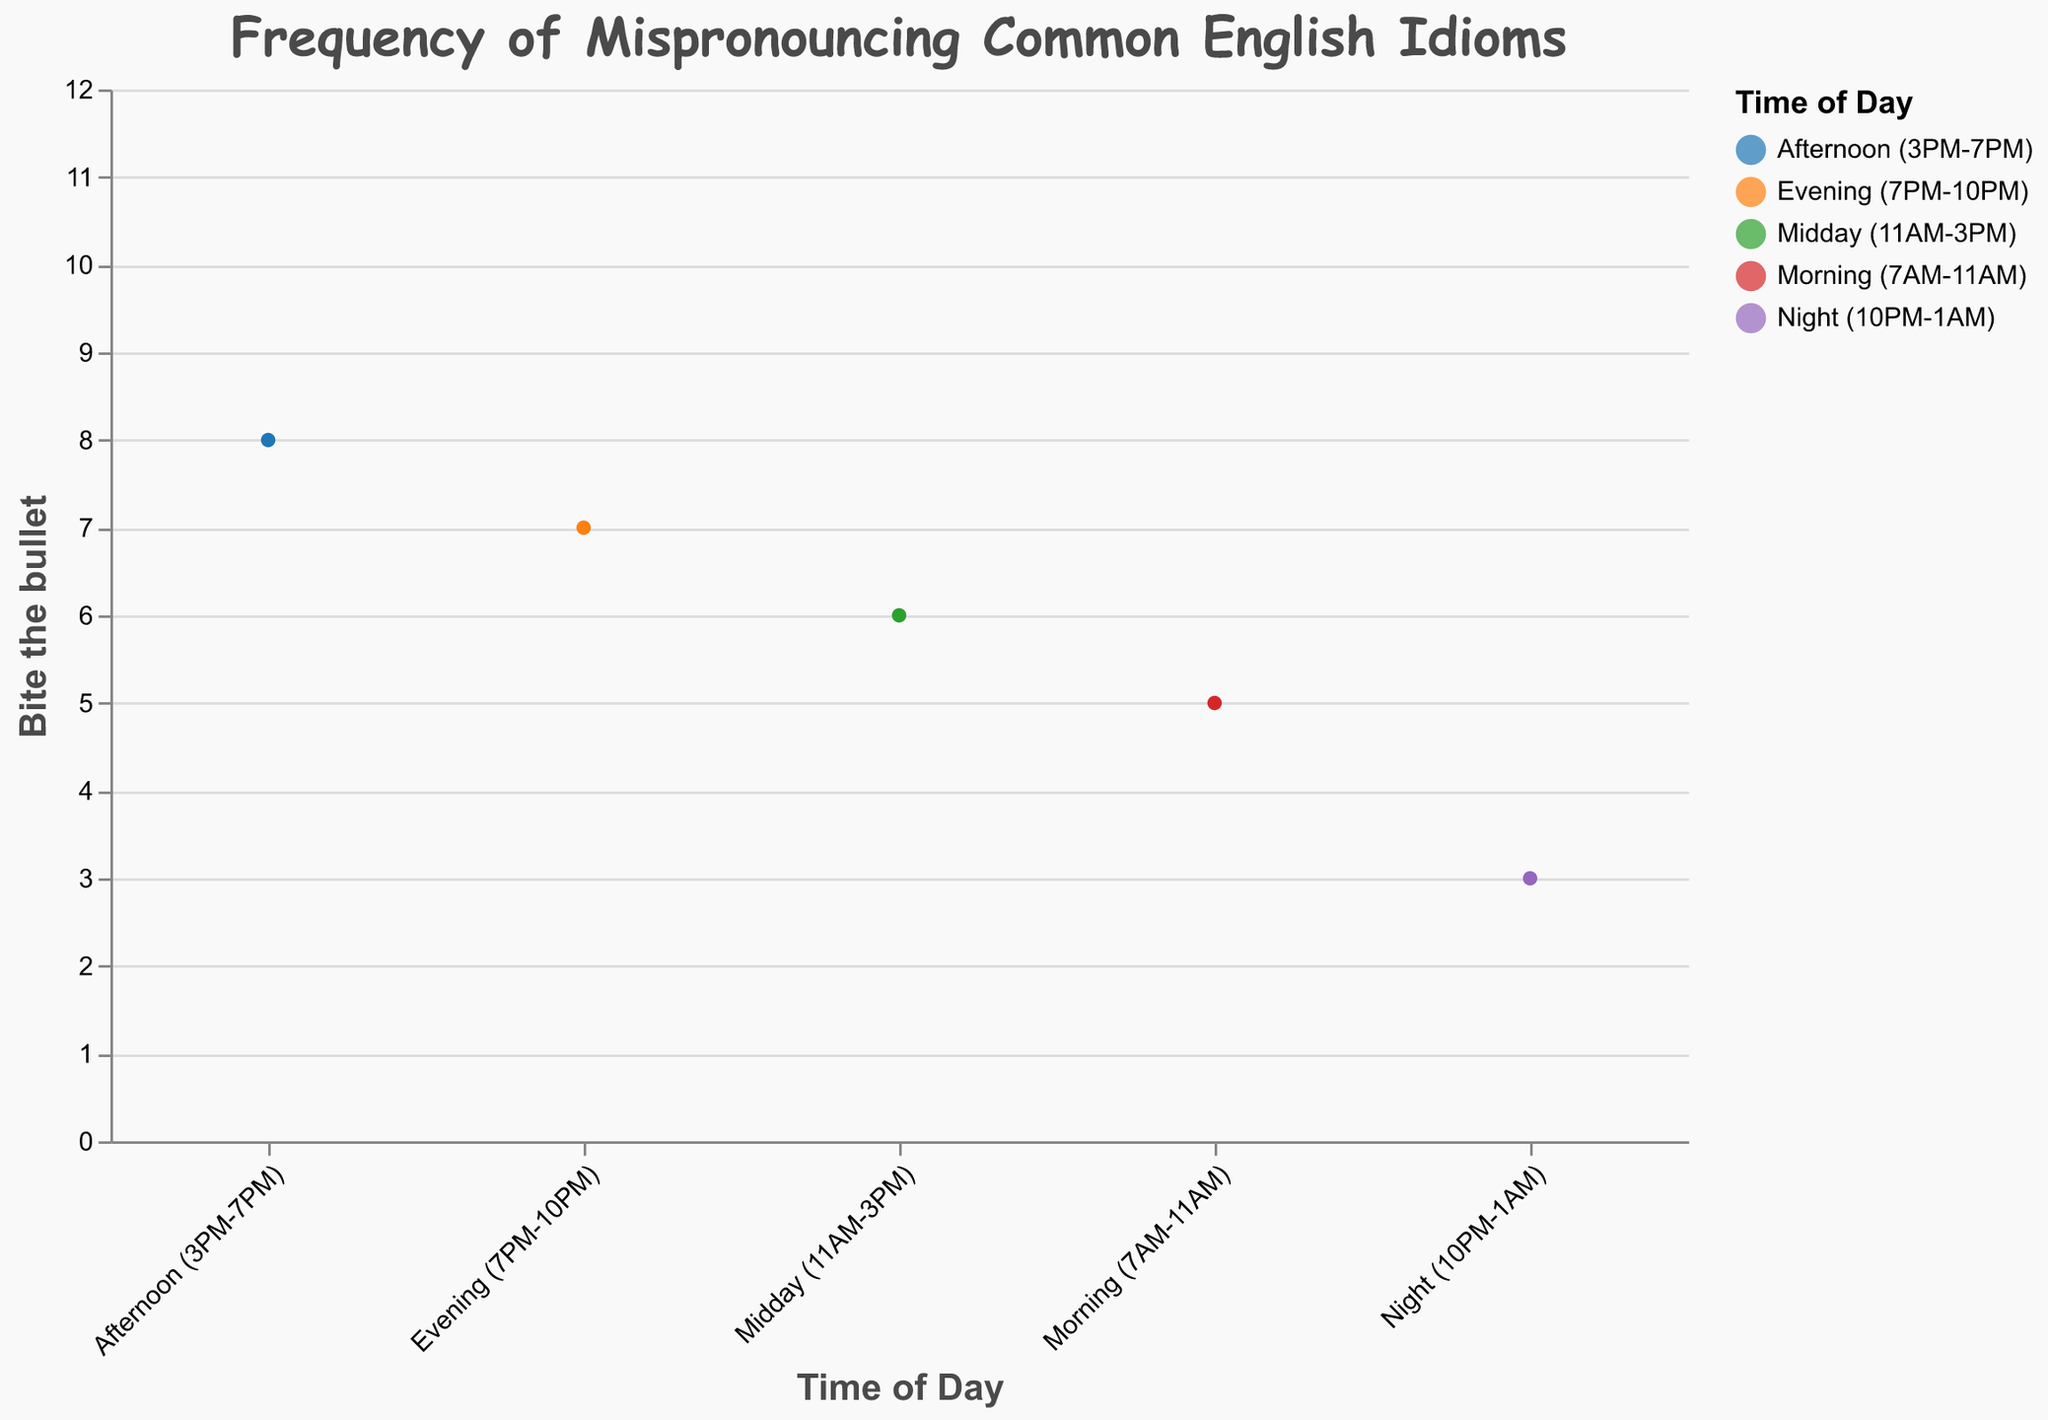What is the highest frequency of mispronouncing idioms during Morning (7AM-11AM)? You need to look at the "Morning (7AM-11AM)" row and find the maximum value among all idioms. The values are 5, 4, 3, 2, 4, 2, 3, and 3. The highest value is 5.
Answer: 5 Which idiom is most frequently mispronounced during Night (10PM-1AM)? Look at the "Night (10PM-1AM)" row and find the highest value. The values are 3, 4, 2, 10, 3, 8, 2, and 2. The highest value is 10, which corresponds to "Hit the sack."
Answer: Hit the sack How does the frequency of "Bite the bullet" change from Midday (11AM-3PM) to Afternoon (3PM-7PM)? The frequency of "Bite the bullet" at Midday is 6, and it increases to 8 in the Afternoon. The change is an increase.
Answer: Increase What is the combined frequency of "Burning the midnight oil" in Evening (7PM-10PM) and Night (10PM-1AM)? The frequency of "Burning the midnight oil" in the Evening is 4 and in the Night is 8. The combined frequency is 4 + 8 = 12.
Answer: 12 Which time of the day has the lowest overall frequency of mispronouncing idioms? Sum the frequencies for each time period. For Morning: 26, Midday: 35, Afternoon: 47, Evening: 42, Night: 34. The lowest sum is in the Morning, with 26.
Answer: Morning (7AM-11AM) Compare the frequency of "Let the cat out of the bag" between Afternoon (3PM-7PM) and Night (10PM-1AM)? The frequency for "Let the cat out of the bag" in the Afternoon is 5 and in the Night is 2. Comparing the two, Afternoon has a higher frequency.
Answer: Afternoon (3PM-7PM) Does the frequency of "Hit the sack" increase or decrease in the Evening (7PM-10PM) compared to the Afternoon (3PM-7PM)? In the Afternoon, the frequency is 4 and in the Evening it is 6. It increases from Afternoon to Evening.
Answer: Increase Which idiom has a frequency of 7 in both the Afternoon (3PM-7PM) and Evening (7PM-10PM)? In the Afternoon, the frequencies are: 8, 7, 6, 4, 7, 3, 5, 6. In the Evening: 7, 6, 5, 6, 5, 4, 5, 4. "Piece of cake" has a frequency of 7 in the Afternoon and 6 in the Evening, while "Cutting corners" has 7 in the Afternoon. Only "Cutting corners" has 7 in both periods.
Answer: Cutting corners 